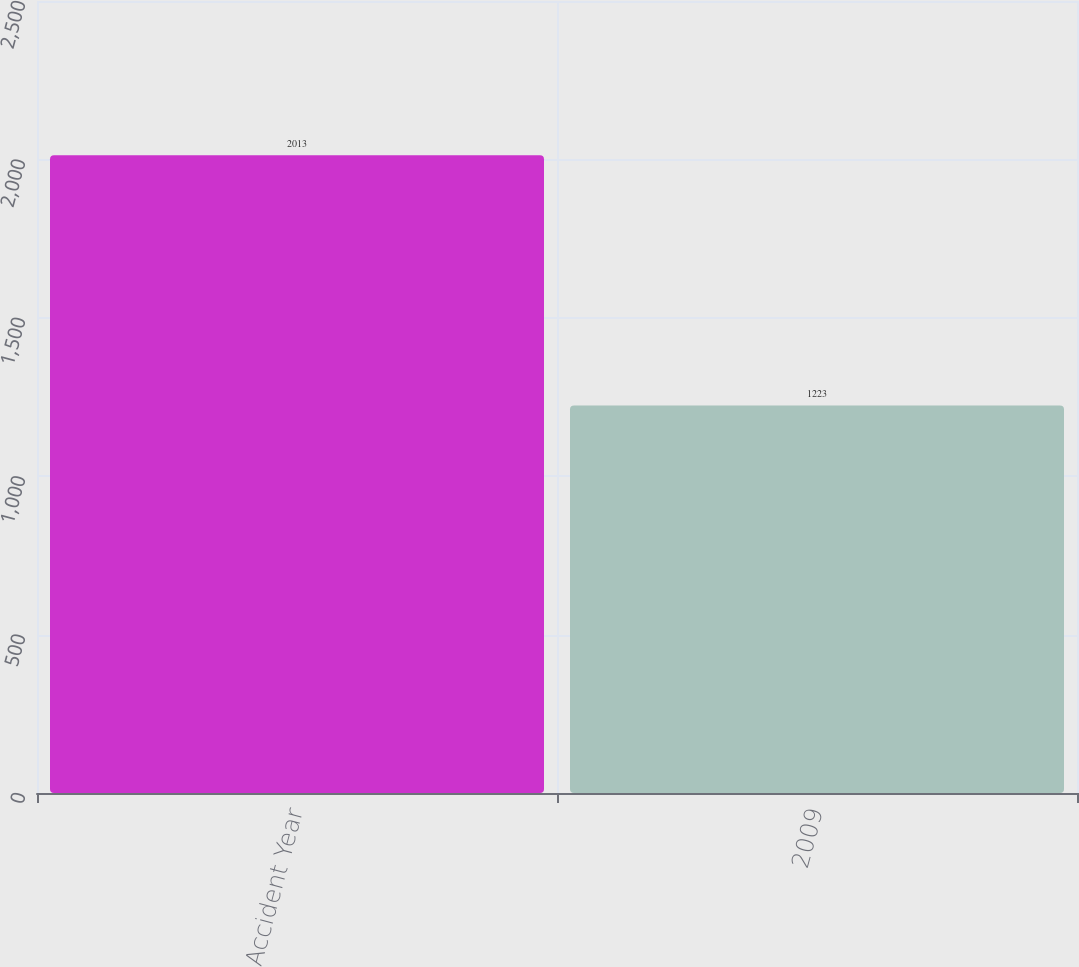Convert chart to OTSL. <chart><loc_0><loc_0><loc_500><loc_500><bar_chart><fcel>Accident Year<fcel>2009<nl><fcel>2013<fcel>1223<nl></chart> 